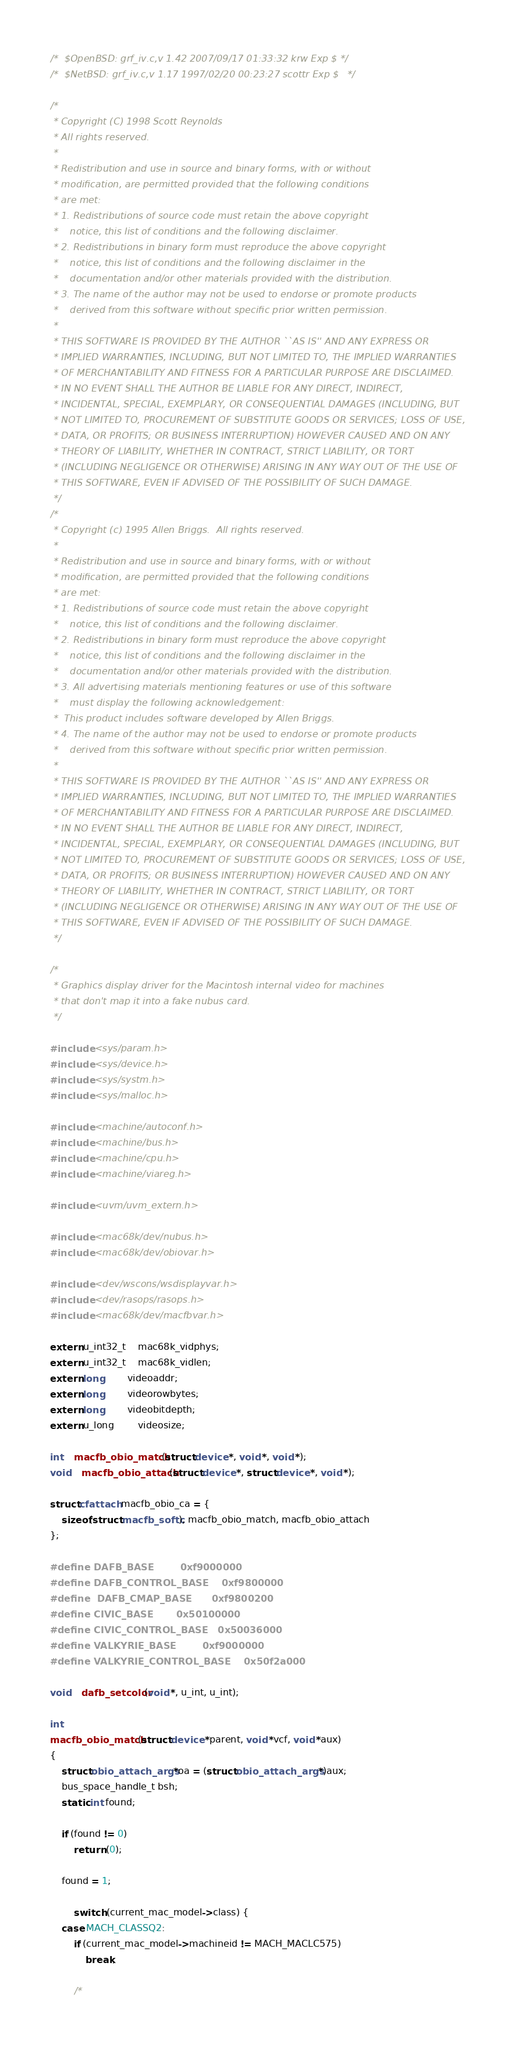<code> <loc_0><loc_0><loc_500><loc_500><_C_>/*	$OpenBSD: grf_iv.c,v 1.42 2007/09/17 01:33:32 krw Exp $	*/
/*	$NetBSD: grf_iv.c,v 1.17 1997/02/20 00:23:27 scottr Exp $	*/

/*
 * Copyright (C) 1998 Scott Reynolds
 * All rights reserved.
 *
 * Redistribution and use in source and binary forms, with or without
 * modification, are permitted provided that the following conditions
 * are met:
 * 1. Redistributions of source code must retain the above copyright
 *    notice, this list of conditions and the following disclaimer.
 * 2. Redistributions in binary form must reproduce the above copyright
 *    notice, this list of conditions and the following disclaimer in the
 *    documentation and/or other materials provided with the distribution.
 * 3. The name of the author may not be used to endorse or promote products
 *    derived from this software without specific prior written permission.
 *
 * THIS SOFTWARE IS PROVIDED BY THE AUTHOR ``AS IS'' AND ANY EXPRESS OR
 * IMPLIED WARRANTIES, INCLUDING, BUT NOT LIMITED TO, THE IMPLIED WARRANTIES
 * OF MERCHANTABILITY AND FITNESS FOR A PARTICULAR PURPOSE ARE DISCLAIMED.
 * IN NO EVENT SHALL THE AUTHOR BE LIABLE FOR ANY DIRECT, INDIRECT,
 * INCIDENTAL, SPECIAL, EXEMPLARY, OR CONSEQUENTIAL DAMAGES (INCLUDING, BUT
 * NOT LIMITED TO, PROCUREMENT OF SUBSTITUTE GOODS OR SERVICES; LOSS OF USE,
 * DATA, OR PROFITS; OR BUSINESS INTERRUPTION) HOWEVER CAUSED AND ON ANY
 * THEORY OF LIABILITY, WHETHER IN CONTRACT, STRICT LIABILITY, OR TORT
 * (INCLUDING NEGLIGENCE OR OTHERWISE) ARISING IN ANY WAY OUT OF THE USE OF
 * THIS SOFTWARE, EVEN IF ADVISED OF THE POSSIBILITY OF SUCH DAMAGE.
 */
/*
 * Copyright (c) 1995 Allen Briggs.  All rights reserved.
 *
 * Redistribution and use in source and binary forms, with or without
 * modification, are permitted provided that the following conditions
 * are met:
 * 1. Redistributions of source code must retain the above copyright
 *    notice, this list of conditions and the following disclaimer.
 * 2. Redistributions in binary form must reproduce the above copyright
 *    notice, this list of conditions and the following disclaimer in the
 *    documentation and/or other materials provided with the distribution.
 * 3. All advertising materials mentioning features or use of this software
 *    must display the following acknowledgement:
 *	This product includes software developed by Allen Briggs.
 * 4. The name of the author may not be used to endorse or promote products
 *    derived from this software without specific prior written permission.
 *
 * THIS SOFTWARE IS PROVIDED BY THE AUTHOR ``AS IS'' AND ANY EXPRESS OR
 * IMPLIED WARRANTIES, INCLUDING, BUT NOT LIMITED TO, THE IMPLIED WARRANTIES
 * OF MERCHANTABILITY AND FITNESS FOR A PARTICULAR PURPOSE ARE DISCLAIMED.
 * IN NO EVENT SHALL THE AUTHOR BE LIABLE FOR ANY DIRECT, INDIRECT,
 * INCIDENTAL, SPECIAL, EXEMPLARY, OR CONSEQUENTIAL DAMAGES (INCLUDING, BUT
 * NOT LIMITED TO, PROCUREMENT OF SUBSTITUTE GOODS OR SERVICES; LOSS OF USE,
 * DATA, OR PROFITS; OR BUSINESS INTERRUPTION) HOWEVER CAUSED AND ON ANY
 * THEORY OF LIABILITY, WHETHER IN CONTRACT, STRICT LIABILITY, OR TORT
 * (INCLUDING NEGLIGENCE OR OTHERWISE) ARISING IN ANY WAY OUT OF THE USE OF
 * THIS SOFTWARE, EVEN IF ADVISED OF THE POSSIBILITY OF SUCH DAMAGE.
 */

/*
 * Graphics display driver for the Macintosh internal video for machines
 * that don't map it into a fake nubus card.
 */

#include <sys/param.h>
#include <sys/device.h>
#include <sys/systm.h>
#include <sys/malloc.h>

#include <machine/autoconf.h>
#include <machine/bus.h>
#include <machine/cpu.h>
#include <machine/viareg.h>

#include <uvm/uvm_extern.h>

#include <mac68k/dev/nubus.h>
#include <mac68k/dev/obiovar.h>

#include <dev/wscons/wsdisplayvar.h>
#include <dev/rasops/rasops.h>
#include <mac68k/dev/macfbvar.h>

extern u_int32_t	mac68k_vidphys;
extern u_int32_t	mac68k_vidlen;
extern long		videoaddr;
extern long		videorowbytes;
extern long		videobitdepth;
extern u_long		videosize;

int	macfb_obio_match(struct device *, void *, void *);
void	macfb_obio_attach(struct device *, struct device *, void *);

struct cfattach macfb_obio_ca = {
	sizeof(struct macfb_softc), macfb_obio_match, macfb_obio_attach
};

#define DAFB_BASE		0xf9000000
#define DAFB_CONTROL_BASE	0xf9800000
#define	DAFB_CMAP_BASE		0xf9800200
#define CIVIC_BASE		0x50100000
#define CIVIC_CONTROL_BASE	0x50036000
#define VALKYRIE_BASE		0xf9000000
#define VALKYRIE_CONTROL_BASE	0x50f2a000

void	dafb_setcolor(void *, u_int, u_int);

int
macfb_obio_match(struct device *parent, void *vcf, void *aux)
{
	struct obio_attach_args *oa = (struct obio_attach_args *)aux;
	bus_space_handle_t bsh;
	static int found;

	if (found != 0)
		return (0);

	found = 1;

        switch (current_mac_model->class) {
	case MACH_CLASSQ2:
		if (current_mac_model->machineid != MACH_MACLC575)
			break;

		/*</code> 